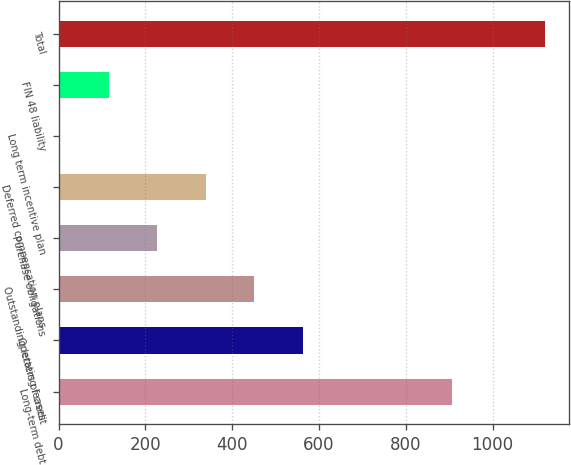Convert chart. <chart><loc_0><loc_0><loc_500><loc_500><bar_chart><fcel>Long-term debt<fcel>Operating leases<fcel>Outstanding letters of credit<fcel>Purchase obligations<fcel>Deferred compensation plans<fcel>Long term incentive plan<fcel>FIN 48 liability<fcel>Total<nl><fcel>905.6<fcel>562.15<fcel>450.5<fcel>227.2<fcel>338.85<fcel>3.9<fcel>115.55<fcel>1120.4<nl></chart> 